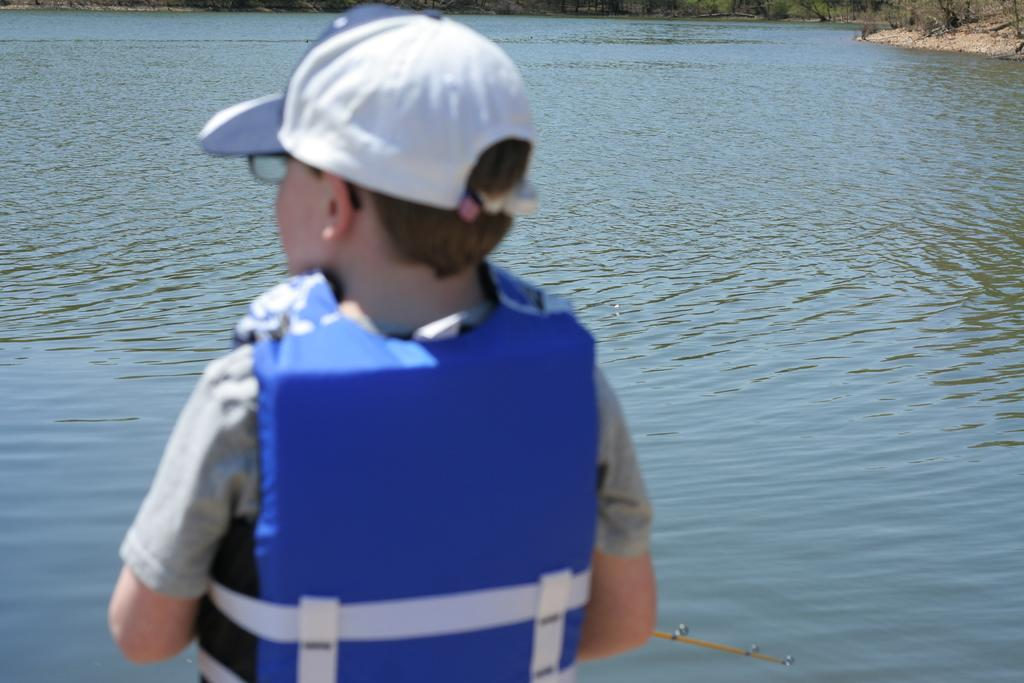Who is in the picture? There is a boy in the picture. What is the boy doing in the picture? The boy is standing towards the water. What is the boy wearing in the picture? The boy is wearing a blue color living jacket and a cap. What can be seen in the distance in the picture? There are trees and a path visible in the distance. What type of jelly can be seen on the calendar in the image? There is no calendar or jelly present in the image. What is the engine used for in the image? There is no engine present in the image. 